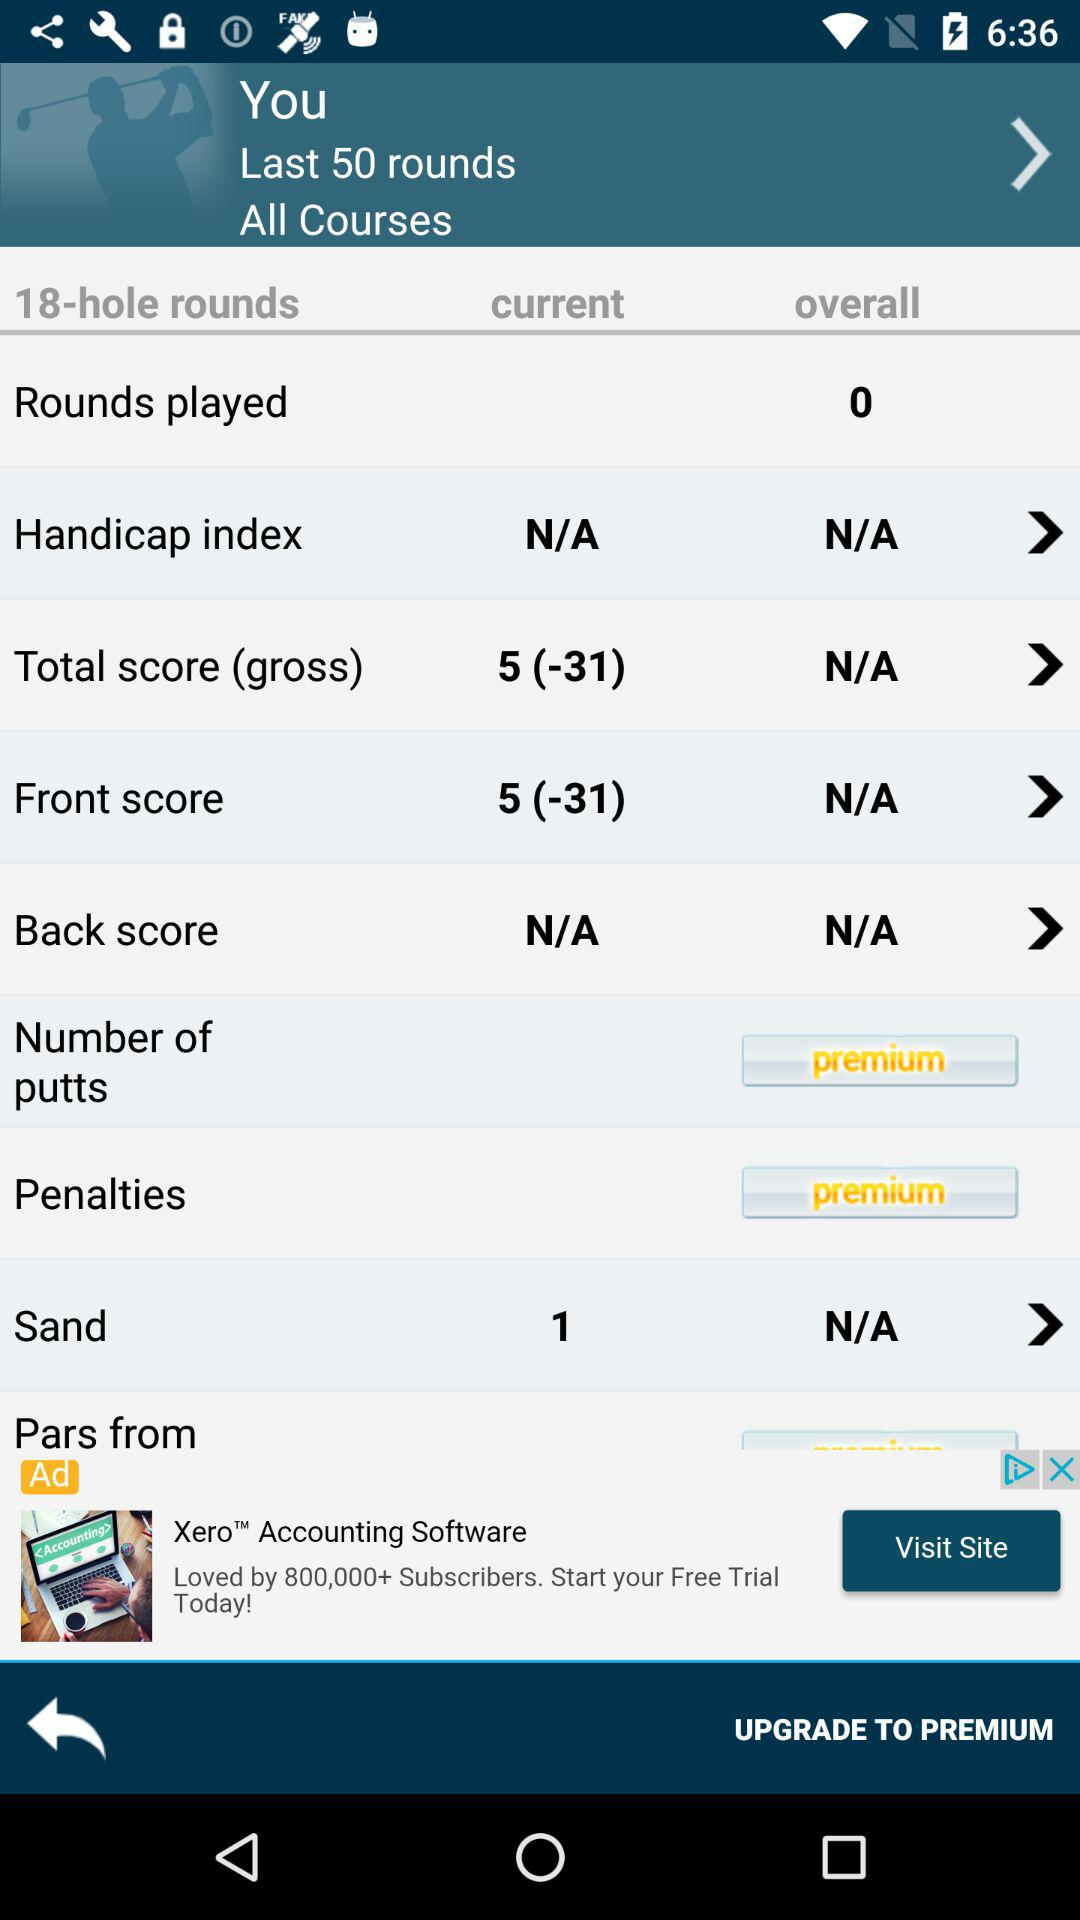How many last rounds are there? There are 50 last rounds. 